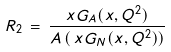Convert formula to latex. <formula><loc_0><loc_0><loc_500><loc_500>R _ { 2 } \, = \, \frac { x G _ { A } ( x , Q ^ { 2 } ) } { A \, ( \, x G _ { N } ( x , Q ^ { 2 } ) ) }</formula> 